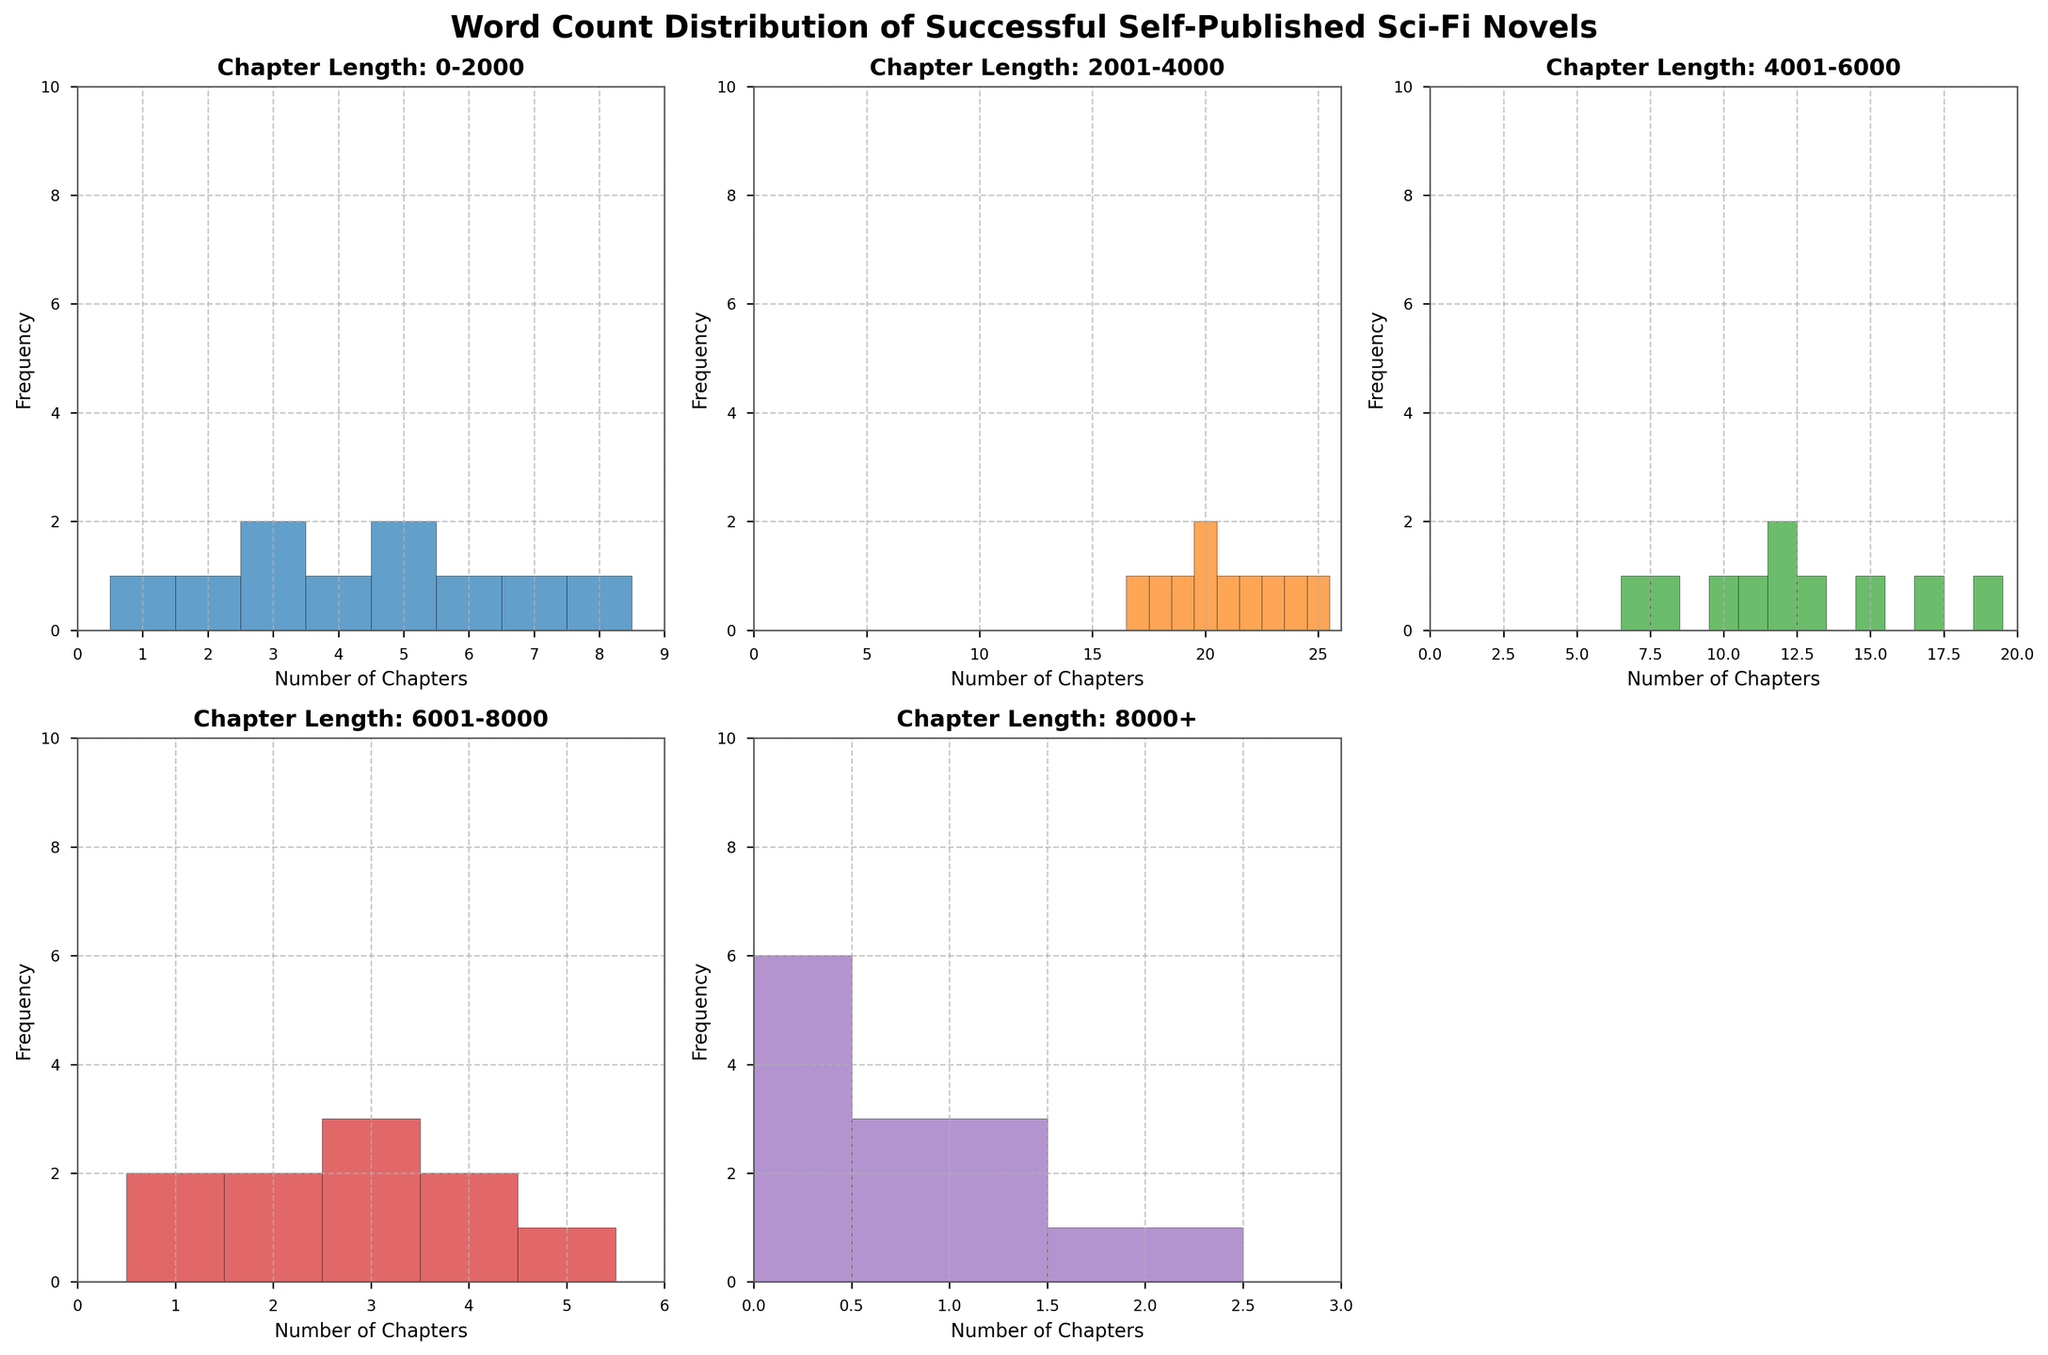What is the title of the figure? The title of a figure is typically located above the main content and often provides a summary of the entire plot. In this case, it's prominently displayed on top in a bold font.
Answer: Word Count Distribution of Successful Self-Published Sci-Fi Novels What does the x-axis represent in the subplot 'Chapter Length: 0-2000'? The x-axis in a histogram indicates the number of chapters falling within the specified chapter length category. For 'Chapter Length: 0-2000', it shows the range of chapters that belong to this short chapter length category.
Answer: Number of Chapters How many novels have exactly 5 chapters in the 'Chapter Length: 0-2000' category? Count the bars that correspond to the value 5 on the x-axis within the subplot 'Chapter Length: 0-2000'. Each bar represents the number of novels that have exactly 5 chapters within that chapter length.
Answer: 2 novels Which chapter length has the highest frequency in the 'Chapter Length: 2001-4000' category? Observe the tallest bar in the histogram for 'Chapter Length: 2001-4000'. The height of a bar indicates the frequency, and the position on the x-axis indicates the number of chapters. The tallest bar identifies the chapter number with the highest frequency.
Answer: 22 chapters How do the frequencies for novels with chapters in the '6001-8000' category compare to those in the '2001-4000' category? Compare the heights of the bars in both histograms. Notice the general trend and height of the bars in these two subplots to understand which category has more frequent chapter lengths.
Answer: The '2001-4000' category generally has higher frequencies Which subplot has the maximum number of novels with chapter lengths greater than 0 but fewer than 2 occurrences? Count the number of bars (if any) within each subplot where the y-axis value falls between 0 but does not reach 2. This gives us the maximum number of chapters falling into that specific range.
Answer: 'Chapter Length: 8000+' How many novels have exactly 12 chapters in the 'Chapter Length: 4001-6000' category? Look at the histogram corresponding to 'Chapter Length: 4001-6000' and find the bar that falls on the 12 chapters mark on the x-axis. The height of this bar shows the number of novels.
Answer: 2 novels In the 'Chapter Length: 0-2000' subplot, which bar represents "The Marsian" by Andy Weir? Since "The Marsian" by Andy Weir has 5 chapters in the 0-2000 length category, you need to find the bar in this subplot that corresponds to 5 chapters.
Answer: The bar at 5 chapters Which novel has the fewest chapters in the 'Chapter Length: 4001-6000' category? Identify the novel with the smallest chapter count within the '4001-6000' category by checking each bar and their corresponding heights. The shortest bar (indicating the fewest chapters) corresponds to "We Are Legion (We Are Bob)" by Dennis E. Taylor with 8 chapters.
Answer: "We Are Legion (We Are Bob)" by Dennis E. Taylor Which subplot shows the widest range of chapter frequencies? Consider the length of the x-axis that each subplot covers and identify which histogram spans the widest range from the minimum to the maximum chapter frequency.
Answer: 'Chapter Length: 2001-4000' 